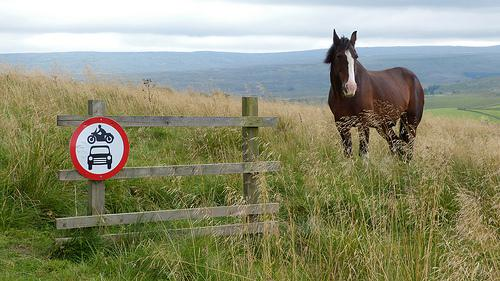Question: what is the fence made of?
Choices:
A. Plastic.
B. Stone.
C. Metal.
D. Wood.
Answer with the letter. Answer: D Question: what color is the horse?
Choices:
A. Black.
B. Grey.
C. Brown.
D. White.
Answer with the letter. Answer: C Question: what is attached to the fence?
Choices:
A. A paper.
B. A sign.
C. Cardboard.
D. A gate.
Answer with the letter. Answer: B Question: what shape is the sign?
Choices:
A. Round.
B. Square.
C. Triangle.
D. Diamond.
Answer with the letter. Answer: A Question: where was this picture taken?
Choices:
A. In a cave.
B. In a stream.
C. In the snow.
D. In a field.
Answer with the letter. Answer: D 